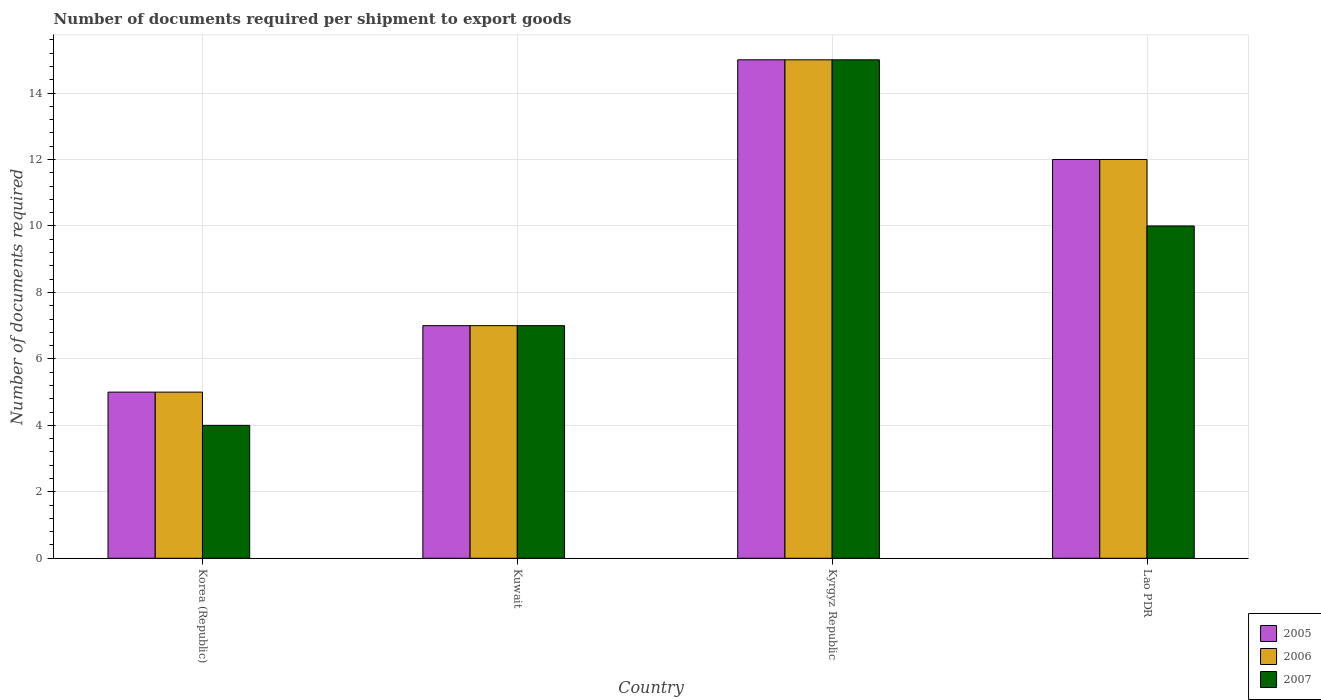How many different coloured bars are there?
Offer a terse response. 3. Are the number of bars per tick equal to the number of legend labels?
Give a very brief answer. Yes. Are the number of bars on each tick of the X-axis equal?
Your response must be concise. Yes. How many bars are there on the 2nd tick from the left?
Provide a succinct answer. 3. How many bars are there on the 4th tick from the right?
Offer a very short reply. 3. What is the label of the 2nd group of bars from the left?
Provide a short and direct response. Kuwait. Across all countries, what is the maximum number of documents required per shipment to export goods in 2007?
Keep it short and to the point. 15. In which country was the number of documents required per shipment to export goods in 2005 maximum?
Your answer should be very brief. Kyrgyz Republic. In which country was the number of documents required per shipment to export goods in 2006 minimum?
Ensure brevity in your answer.  Korea (Republic). What is the total number of documents required per shipment to export goods in 2006 in the graph?
Give a very brief answer. 39. What is the average number of documents required per shipment to export goods in 2005 per country?
Keep it short and to the point. 9.75. What is the difference between the number of documents required per shipment to export goods of/in 2006 and number of documents required per shipment to export goods of/in 2007 in Kyrgyz Republic?
Offer a very short reply. 0. In how many countries, is the number of documents required per shipment to export goods in 2006 greater than 14.4?
Offer a very short reply. 1. What is the ratio of the number of documents required per shipment to export goods in 2007 in Kuwait to that in Kyrgyz Republic?
Provide a succinct answer. 0.47. What is the difference between the highest and the second highest number of documents required per shipment to export goods in 2006?
Keep it short and to the point. 5. What does the 2nd bar from the left in Kyrgyz Republic represents?
Your answer should be very brief. 2006. What does the 3rd bar from the right in Kyrgyz Republic represents?
Provide a succinct answer. 2005. Is it the case that in every country, the sum of the number of documents required per shipment to export goods in 2005 and number of documents required per shipment to export goods in 2006 is greater than the number of documents required per shipment to export goods in 2007?
Provide a succinct answer. Yes. How many countries are there in the graph?
Provide a short and direct response. 4. Are the values on the major ticks of Y-axis written in scientific E-notation?
Make the answer very short. No. Does the graph contain any zero values?
Make the answer very short. No. Where does the legend appear in the graph?
Offer a very short reply. Bottom right. How are the legend labels stacked?
Give a very brief answer. Vertical. What is the title of the graph?
Offer a terse response. Number of documents required per shipment to export goods. What is the label or title of the X-axis?
Provide a succinct answer. Country. What is the label or title of the Y-axis?
Make the answer very short. Number of documents required. What is the Number of documents required in 2005 in Korea (Republic)?
Keep it short and to the point. 5. What is the Number of documents required of 2006 in Korea (Republic)?
Your response must be concise. 5. What is the Number of documents required of 2007 in Kuwait?
Provide a short and direct response. 7. What is the Number of documents required in 2006 in Kyrgyz Republic?
Provide a succinct answer. 15. What is the Number of documents required in 2005 in Lao PDR?
Offer a very short reply. 12. What is the Number of documents required in 2006 in Lao PDR?
Provide a succinct answer. 12. Across all countries, what is the maximum Number of documents required of 2005?
Make the answer very short. 15. Across all countries, what is the maximum Number of documents required in 2006?
Offer a very short reply. 15. Across all countries, what is the maximum Number of documents required of 2007?
Offer a terse response. 15. What is the total Number of documents required of 2005 in the graph?
Offer a terse response. 39. What is the difference between the Number of documents required of 2006 in Korea (Republic) and that in Kuwait?
Your answer should be very brief. -2. What is the difference between the Number of documents required of 2007 in Korea (Republic) and that in Lao PDR?
Offer a very short reply. -6. What is the difference between the Number of documents required of 2005 in Kuwait and that in Kyrgyz Republic?
Offer a very short reply. -8. What is the difference between the Number of documents required in 2006 in Kuwait and that in Kyrgyz Republic?
Keep it short and to the point. -8. What is the difference between the Number of documents required in 2007 in Kuwait and that in Kyrgyz Republic?
Your answer should be very brief. -8. What is the difference between the Number of documents required in 2006 in Kuwait and that in Lao PDR?
Your answer should be very brief. -5. What is the difference between the Number of documents required in 2007 in Kuwait and that in Lao PDR?
Your response must be concise. -3. What is the difference between the Number of documents required of 2005 in Kyrgyz Republic and that in Lao PDR?
Keep it short and to the point. 3. What is the difference between the Number of documents required of 2005 in Korea (Republic) and the Number of documents required of 2006 in Kuwait?
Make the answer very short. -2. What is the difference between the Number of documents required in 2005 in Korea (Republic) and the Number of documents required in 2007 in Lao PDR?
Your response must be concise. -5. What is the difference between the Number of documents required of 2005 in Kuwait and the Number of documents required of 2007 in Kyrgyz Republic?
Your answer should be very brief. -8. What is the difference between the Number of documents required of 2005 in Kyrgyz Republic and the Number of documents required of 2006 in Lao PDR?
Ensure brevity in your answer.  3. What is the difference between the Number of documents required of 2005 in Kyrgyz Republic and the Number of documents required of 2007 in Lao PDR?
Your answer should be compact. 5. What is the average Number of documents required in 2005 per country?
Provide a short and direct response. 9.75. What is the average Number of documents required of 2006 per country?
Ensure brevity in your answer.  9.75. What is the difference between the Number of documents required in 2005 and Number of documents required in 2006 in Korea (Republic)?
Provide a short and direct response. 0. What is the difference between the Number of documents required in 2005 and Number of documents required in 2007 in Korea (Republic)?
Make the answer very short. 1. What is the difference between the Number of documents required of 2005 and Number of documents required of 2007 in Kuwait?
Your answer should be very brief. 0. What is the difference between the Number of documents required of 2006 and Number of documents required of 2007 in Kuwait?
Provide a short and direct response. 0. What is the difference between the Number of documents required of 2005 and Number of documents required of 2006 in Kyrgyz Republic?
Offer a very short reply. 0. What is the difference between the Number of documents required in 2005 and Number of documents required in 2007 in Kyrgyz Republic?
Ensure brevity in your answer.  0. What is the difference between the Number of documents required of 2006 and Number of documents required of 2007 in Lao PDR?
Provide a succinct answer. 2. What is the ratio of the Number of documents required of 2007 in Korea (Republic) to that in Kuwait?
Your answer should be very brief. 0.57. What is the ratio of the Number of documents required of 2006 in Korea (Republic) to that in Kyrgyz Republic?
Ensure brevity in your answer.  0.33. What is the ratio of the Number of documents required in 2007 in Korea (Republic) to that in Kyrgyz Republic?
Give a very brief answer. 0.27. What is the ratio of the Number of documents required in 2005 in Korea (Republic) to that in Lao PDR?
Offer a terse response. 0.42. What is the ratio of the Number of documents required of 2006 in Korea (Republic) to that in Lao PDR?
Your response must be concise. 0.42. What is the ratio of the Number of documents required in 2005 in Kuwait to that in Kyrgyz Republic?
Your answer should be compact. 0.47. What is the ratio of the Number of documents required in 2006 in Kuwait to that in Kyrgyz Republic?
Give a very brief answer. 0.47. What is the ratio of the Number of documents required of 2007 in Kuwait to that in Kyrgyz Republic?
Give a very brief answer. 0.47. What is the ratio of the Number of documents required of 2005 in Kuwait to that in Lao PDR?
Your answer should be very brief. 0.58. What is the ratio of the Number of documents required in 2006 in Kuwait to that in Lao PDR?
Provide a succinct answer. 0.58. What is the difference between the highest and the second highest Number of documents required in 2006?
Ensure brevity in your answer.  3. What is the difference between the highest and the lowest Number of documents required of 2006?
Offer a very short reply. 10. What is the difference between the highest and the lowest Number of documents required of 2007?
Make the answer very short. 11. 